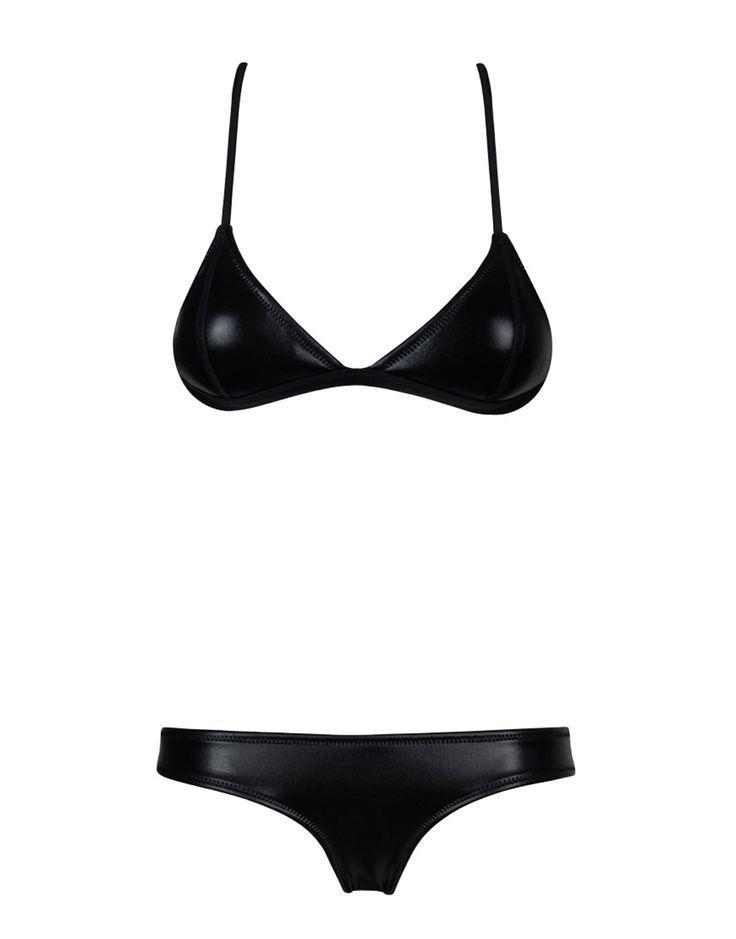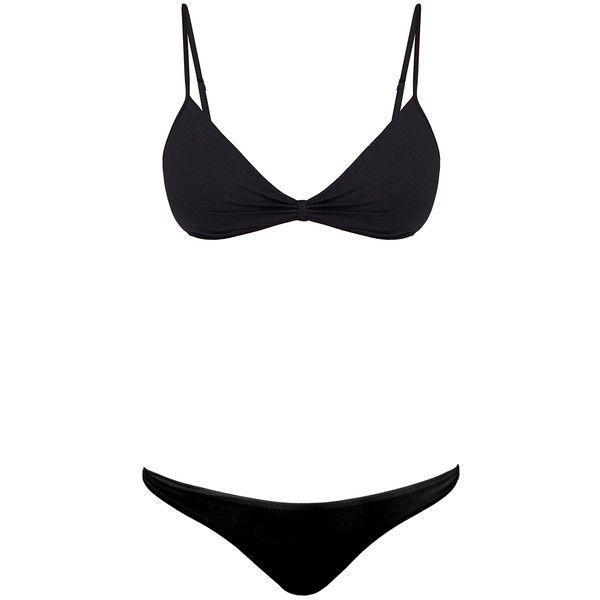The first image is the image on the left, the second image is the image on the right. Evaluate the accuracy of this statement regarding the images: "Both swimsuits are primarily black in color". Is it true? Answer yes or no. Yes. 